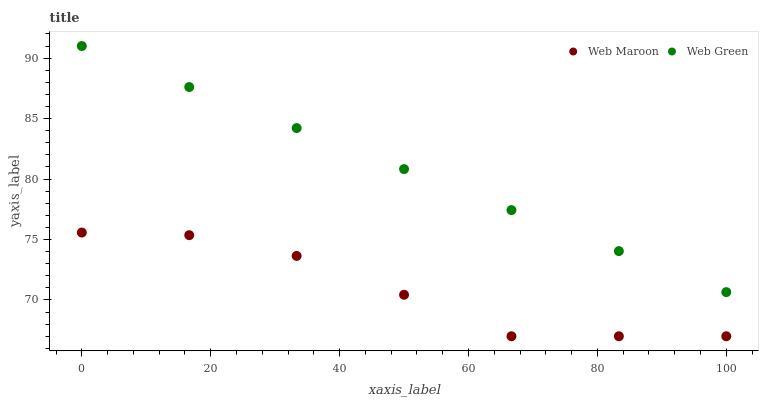Does Web Maroon have the minimum area under the curve?
Answer yes or no. Yes. Does Web Green have the maximum area under the curve?
Answer yes or no. Yes. Does Web Green have the minimum area under the curve?
Answer yes or no. No. Is Web Green the smoothest?
Answer yes or no. Yes. Is Web Maroon the roughest?
Answer yes or no. Yes. Is Web Green the roughest?
Answer yes or no. No. Does Web Maroon have the lowest value?
Answer yes or no. Yes. Does Web Green have the lowest value?
Answer yes or no. No. Does Web Green have the highest value?
Answer yes or no. Yes. Is Web Maroon less than Web Green?
Answer yes or no. Yes. Is Web Green greater than Web Maroon?
Answer yes or no. Yes. Does Web Maroon intersect Web Green?
Answer yes or no. No. 